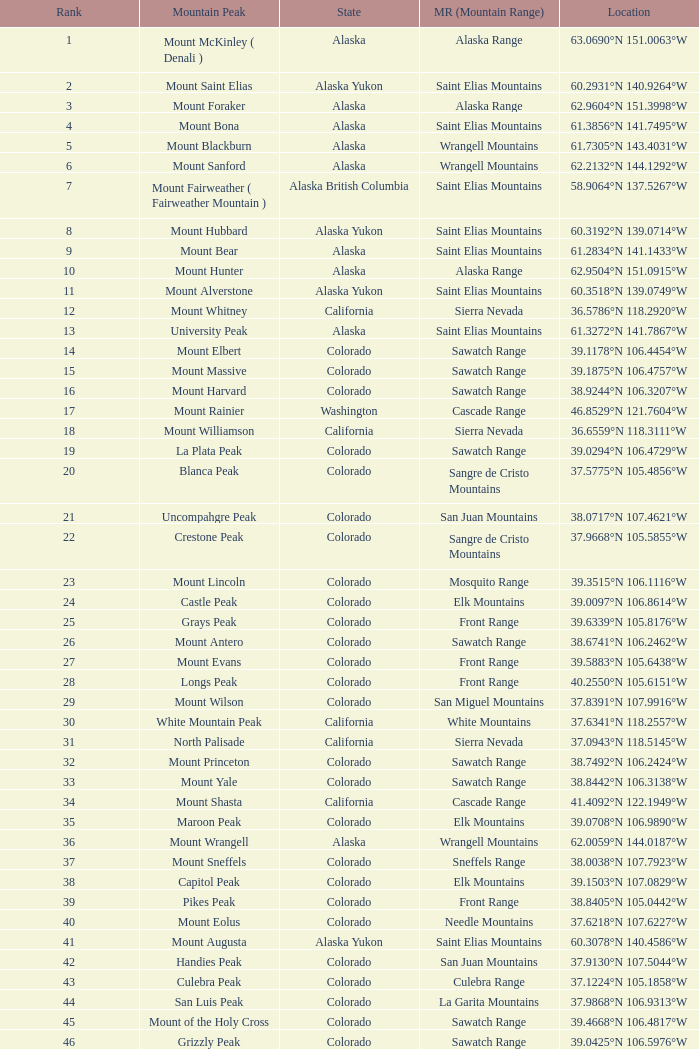What is the mountain range when the mountain peak is mauna kea? Island of Hawai ʻ i. 